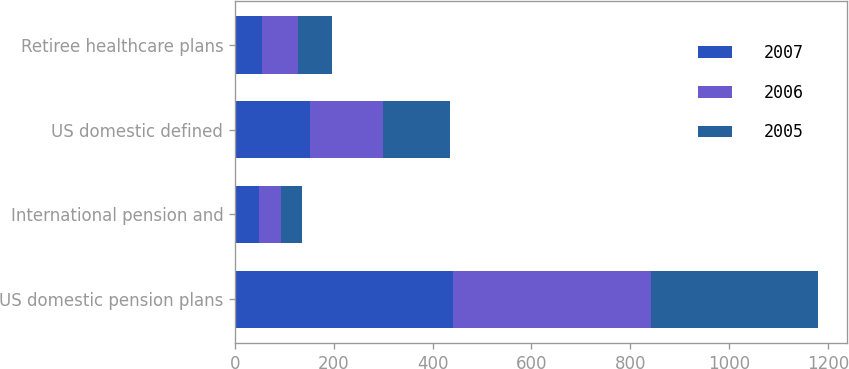Convert chart. <chart><loc_0><loc_0><loc_500><loc_500><stacked_bar_chart><ecel><fcel>US domestic pension plans<fcel>International pension and<fcel>US domestic defined<fcel>Retiree healthcare plans<nl><fcel>2007<fcel>442<fcel>49<fcel>152<fcel>55<nl><fcel>2006<fcel>400<fcel>45<fcel>147<fcel>73<nl><fcel>2005<fcel>337<fcel>41<fcel>136<fcel>68<nl></chart> 